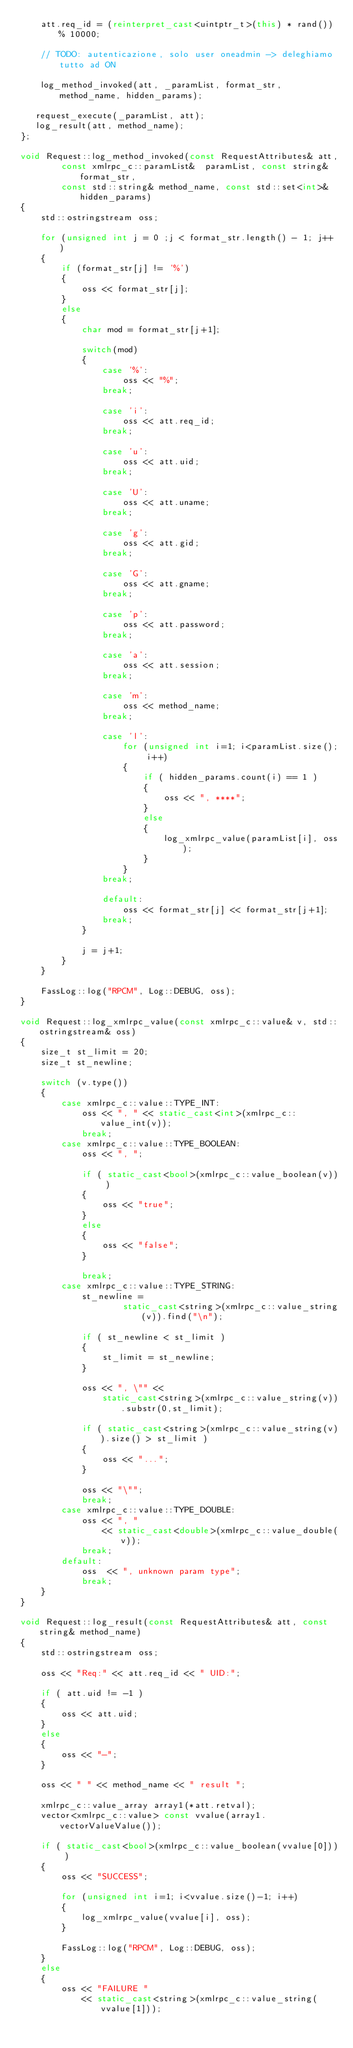<code> <loc_0><loc_0><loc_500><loc_500><_C++_>    att.req_id = (reinterpret_cast<uintptr_t>(this) * rand()) % 10000;

    // TODO: autenticazione, solo user oneadmin -> deleghiamo tutto ad ON
   
    log_method_invoked(att, _paramList, format_str, method_name, hidden_params);
   
   request_execute(_paramList, att);  
   log_result(att, method_name);
};

void Request::log_method_invoked(const RequestAttributes& att,
        const xmlrpc_c::paramList&  paramList, const string& format_str,
        const std::string& method_name, const std::set<int>& hidden_params)
{
    std::ostringstream oss;

    for (unsigned int j = 0 ;j < format_str.length() - 1; j++ )
    {
        if (format_str[j] != '%')
        {
            oss << format_str[j];
        }
        else
        {
            char mod = format_str[j+1];

            switch(mod)
            {
                case '%':
                    oss << "%";
                break;

                case 'i':
                    oss << att.req_id;
                break;

                case 'u':
                    oss << att.uid;
                break;

                case 'U':
                    oss << att.uname;
                break;

                case 'g':
                    oss << att.gid;
                break;

                case 'G':
                    oss << att.gname;
                break;

                case 'p':
                    oss << att.password;
                break;

                case 'a':
                    oss << att.session;
                break;

                case 'm':
                    oss << method_name;
                break;

                case 'l':
                    for (unsigned int i=1; i<paramList.size(); i++)
                    {
                        if ( hidden_params.count(i) == 1 )
                        {
                            oss << ", ****";
                        }
                        else
                        {
                            log_xmlrpc_value(paramList[i], oss);
                        }
                    }
                break;

                default:
                    oss << format_str[j] << format_str[j+1];
                break;
            }

            j = j+1;
        }
    }

    FassLog::log("RPCM", Log::DEBUG, oss);
}

void Request::log_xmlrpc_value(const xmlrpc_c::value& v, std::ostringstream& oss)
{
    size_t st_limit = 20;
    size_t st_newline;

    switch (v.type())
    {
        case xmlrpc_c::value::TYPE_INT:
            oss << ", " << static_cast<int>(xmlrpc_c::value_int(v));
            break;
        case xmlrpc_c::value::TYPE_BOOLEAN:
            oss << ", ";

            if ( static_cast<bool>(xmlrpc_c::value_boolean(v)) )
            {
                oss << "true";
            }
            else
            {
                oss << "false";
            }

            break;
        case xmlrpc_c::value::TYPE_STRING:
            st_newline =
                    static_cast<string>(xmlrpc_c::value_string(v)).find("\n");

            if ( st_newline < st_limit )
            {
                st_limit = st_newline;
            }

            oss << ", \"" <<
                static_cast<string>(xmlrpc_c::value_string(v)).substr(0,st_limit);

            if ( static_cast<string>(xmlrpc_c::value_string(v)).size() > st_limit )
            {
                oss << "...";
            }

            oss << "\"";
            break;
        case xmlrpc_c::value::TYPE_DOUBLE:
            oss << ", "
                << static_cast<double>(xmlrpc_c::value_double(v));
            break;
        default:
            oss  << ", unknown param type";
            break;
    }
}

void Request::log_result(const RequestAttributes& att, const string& method_name)
{
    std::ostringstream oss;

    oss << "Req:" << att.req_id << " UID:";

    if ( att.uid != -1 )
    {
        oss << att.uid;
    }
    else
    {
        oss << "-";
    }

    oss << " " << method_name << " result ";

    xmlrpc_c::value_array array1(*att.retval);
    vector<xmlrpc_c::value> const vvalue(array1.vectorValueValue());

    if ( static_cast<bool>(xmlrpc_c::value_boolean(vvalue[0])) )
    {
        oss << "SUCCESS";

        for (unsigned int i=1; i<vvalue.size()-1; i++)
        {
            log_xmlrpc_value(vvalue[i], oss);
        }

        FassLog::log("RPCM", Log::DEBUG, oss);
    }
    else
    {
        oss << "FAILURE "
            << static_cast<string>(xmlrpc_c::value_string(vvalue[1]));
</code> 